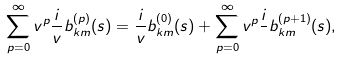<formula> <loc_0><loc_0><loc_500><loc_500>\sum _ { p = 0 } ^ { \infty } v ^ { p } \frac { i } { v } b _ { k m } ^ { ( p ) } ( s ) = \frac { i } { v } b _ { k m } ^ { ( 0 ) } ( s ) + \sum _ { p = 0 } ^ { \infty } v ^ { p } \frac { i } { } b _ { k m } ^ { ( p + 1 ) } ( s ) ,</formula> 